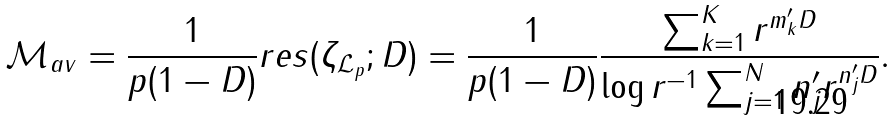<formula> <loc_0><loc_0><loc_500><loc_500>\mathcal { M } _ { a v } = \frac { 1 } { p ( 1 - D ) } r e s ( \zeta _ { \mathcal { L } _ { p } } ; D ) = \frac { 1 } { p ( 1 - D ) } \frac { \sum _ { k = 1 } ^ { K } r ^ { m _ { k } ^ { \prime } D } } { \log { r ^ { - 1 } } \sum _ { j = 1 } ^ { N } n _ { j } ^ { \prime } r ^ { n _ { j } ^ { \prime } D } } .</formula> 